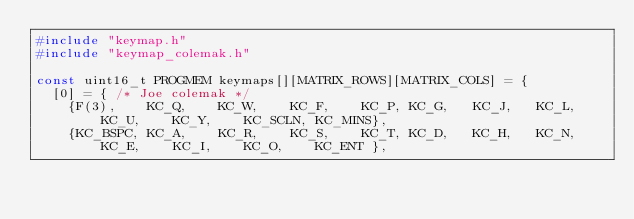Convert code to text. <code><loc_0><loc_0><loc_500><loc_500><_C_>#include "keymap.h"
#include "keymap_colemak.h"

const uint16_t PROGMEM keymaps[][MATRIX_ROWS][MATRIX_COLS] = {
  [0] = { /* Joe colemak */
    {F(3),    KC_Q,    KC_W,    KC_F,    KC_P, KC_G,   KC_J,   KC_L, KC_U,    KC_Y,    KC_SCLN, KC_MINS},
    {KC_BSPC, KC_A,    KC_R,    KC_S,    KC_T, KC_D,   KC_H,   KC_N, KC_E,    KC_I,    KC_O,    KC_ENT },</code> 